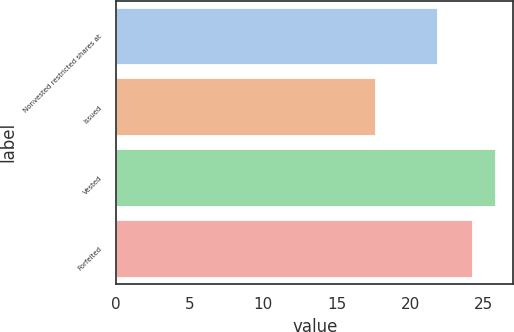Convert chart to OTSL. <chart><loc_0><loc_0><loc_500><loc_500><bar_chart><fcel>Nonvested restricted shares at<fcel>Issued<fcel>Vested<fcel>Forfeited<nl><fcel>21.82<fcel>17.57<fcel>25.72<fcel>24.16<nl></chart> 